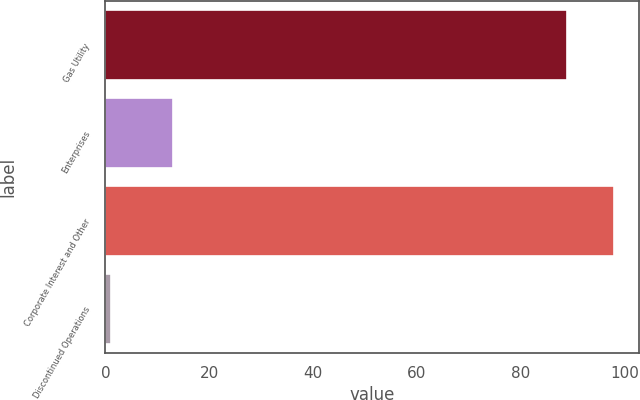Convert chart to OTSL. <chart><loc_0><loc_0><loc_500><loc_500><bar_chart><fcel>Gas Utility<fcel>Enterprises<fcel>Corporate Interest and Other<fcel>Discontinued Operations<nl><fcel>89<fcel>13<fcel>97.9<fcel>1<nl></chart> 